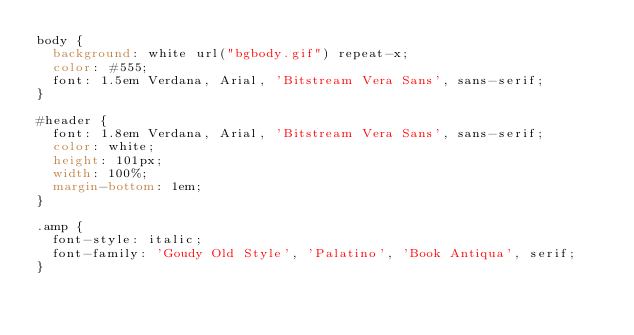<code> <loc_0><loc_0><loc_500><loc_500><_CSS_>body {
  background: white url("bgbody.gif") repeat-x;
  color: #555;
  font: 1.5em Verdana, Arial, 'Bitstream Vera Sans', sans-serif;
}

#header {
  font: 1.8em Verdana, Arial, 'Bitstream Vera Sans', sans-serif;
  color: white;
  height: 101px;
  width: 100%;
  margin-bottom: 1em;
}

.amp {
  font-style: italic;
  font-family: 'Goudy Old Style', 'Palatino', 'Book Antiqua', serif;
}
</code> 